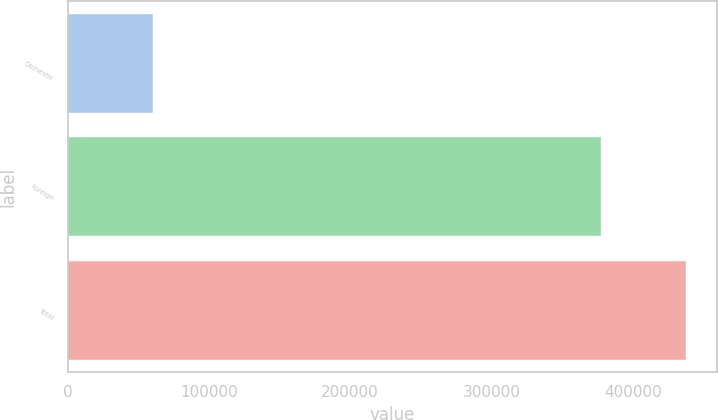Convert chart. <chart><loc_0><loc_0><loc_500><loc_500><bar_chart><fcel>Domestic<fcel>Foreign<fcel>Total<nl><fcel>60470<fcel>377393<fcel>437863<nl></chart> 